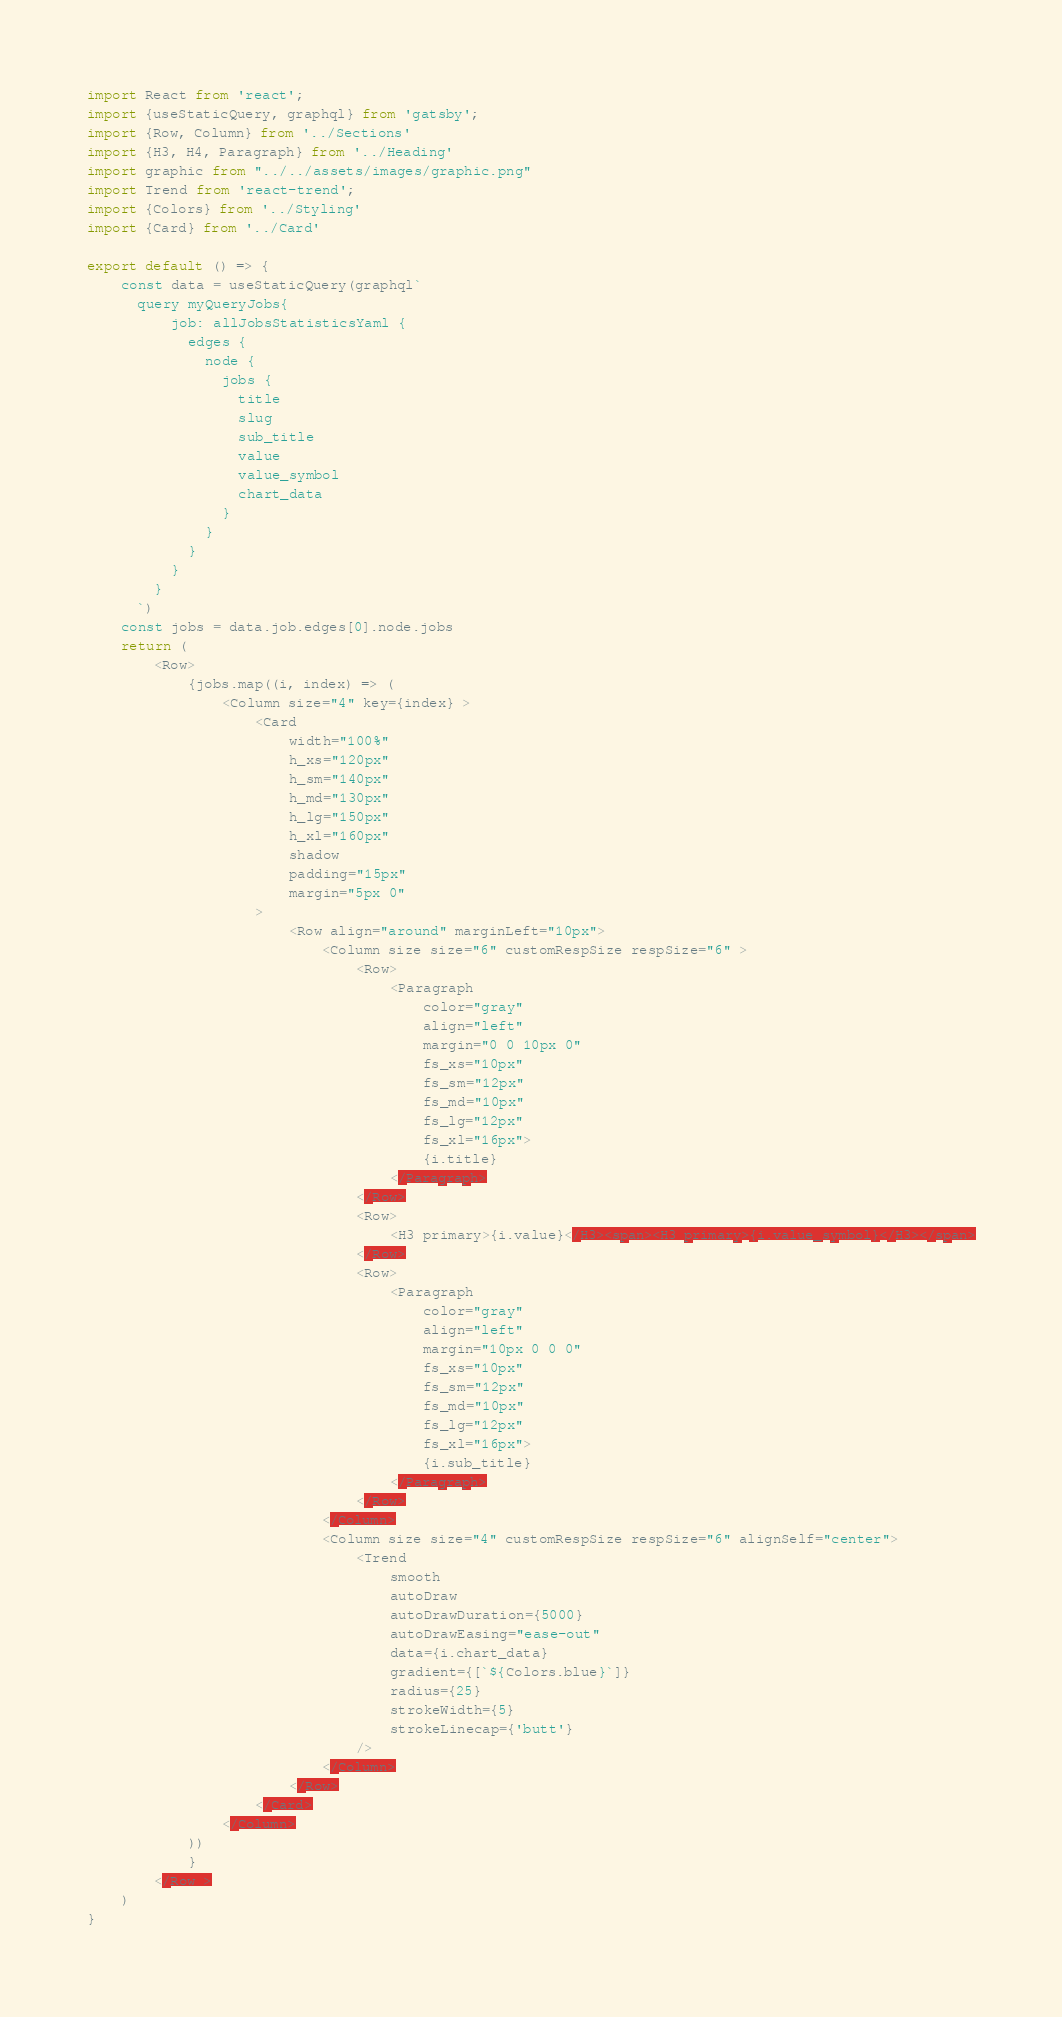Convert code to text. <code><loc_0><loc_0><loc_500><loc_500><_JavaScript_>import React from 'react';
import {useStaticQuery, graphql} from 'gatsby';
import {Row, Column} from '../Sections'
import {H3, H4, Paragraph} from '../Heading'
import graphic from "../../assets/images/graphic.png"
import Trend from 'react-trend';
import {Colors} from '../Styling'
import {Card} from '../Card'

export default () => {
    const data = useStaticQuery(graphql`
      query myQueryJobs{
          job: allJobsStatisticsYaml {
            edges {
              node {
                jobs {
                  title
                  slug
                  sub_title
                  value
                  value_symbol
                  chart_data
                }
              }
            }
          }
        }
      `)
    const jobs = data.job.edges[0].node.jobs
    return (
        <Row>
            {jobs.map((i, index) => (
                <Column size="4" key={index} >
                    <Card
                        width="100%"
                        h_xs="120px"
                        h_sm="140px"
                        h_md="130px"
                        h_lg="150px"
                        h_xl="160px"
                        shadow
                        padding="15px"
                        margin="5px 0"
                    >
                        <Row align="around" marginLeft="10px">
                            <Column size size="6" customRespSize respSize="6" >
                                <Row>
                                    <Paragraph
                                        color="gray"
                                        align="left"
                                        margin="0 0 10px 0"
                                        fs_xs="10px"
                                        fs_sm="12px"
                                        fs_md="10px"
                                        fs_lg="12px"
                                        fs_xl="16px">
                                        {i.title}
                                    </Paragraph>
                                </Row>
                                <Row>
                                    <H3 primary>{i.value}</H3><span><H3 primary>{i.value_symbol}</H3></span>
                                </Row>
                                <Row>
                                    <Paragraph
                                        color="gray"
                                        align="left"
                                        margin="10px 0 0 0"
                                        fs_xs="10px"
                                        fs_sm="12px"
                                        fs_md="10px"
                                        fs_lg="12px"
                                        fs_xl="16px">
                                        {i.sub_title}
                                    </Paragraph>
                                </Row>
                            </Column>
                            <Column size size="4" customRespSize respSize="6" alignSelf="center">
                                <Trend
                                    smooth
                                    autoDraw
                                    autoDrawDuration={5000}
                                    autoDrawEasing="ease-out"
                                    data={i.chart_data}
                                    gradient={[`${Colors.blue}`]}
                                    radius={25}
                                    strokeWidth={5}
                                    strokeLinecap={'butt'}
                                />
                            </Column>
                        </Row>
                    </Card>
                </Column>
            ))
            }
        </Row >
    )
}


</code> 